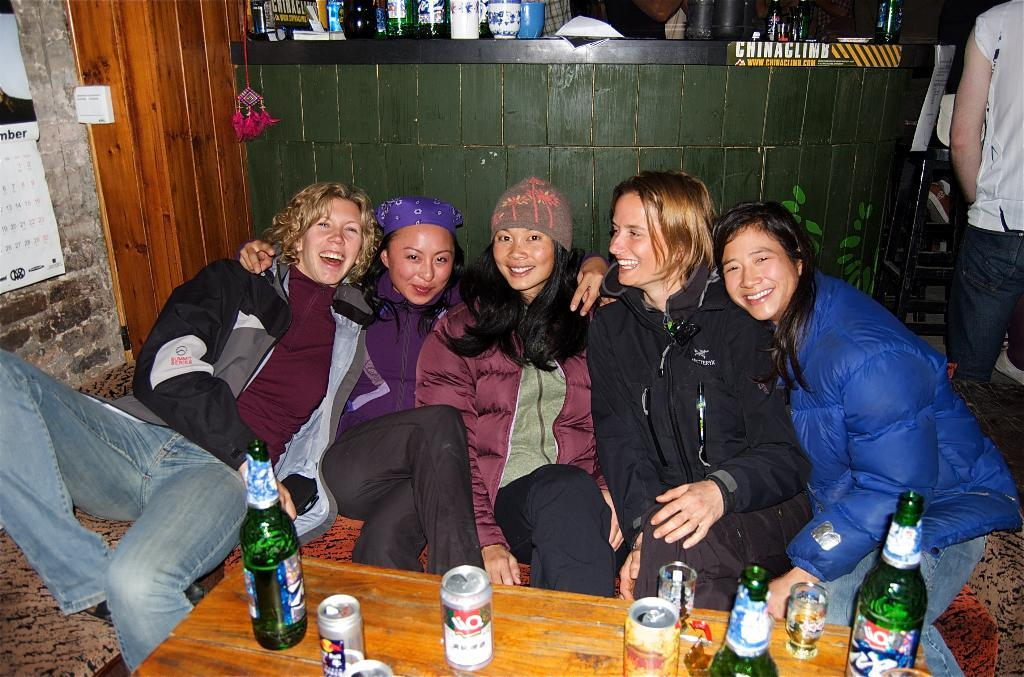What type of structure is visible in the image? There is a brick wall in the image. What are the people in the image doing? The people in the image are sitting. What piece of furniture is present in the image? There is a table in the image. What items can be seen on the table? There are bottles, glasses, and tins on the table. What type of polish is being applied to the table in the image? There is no indication in the image that any polish is being applied to the table. What is the aftermath of the event depicted in the image? The image does not depict an event, so there is no aftermath to describe. 